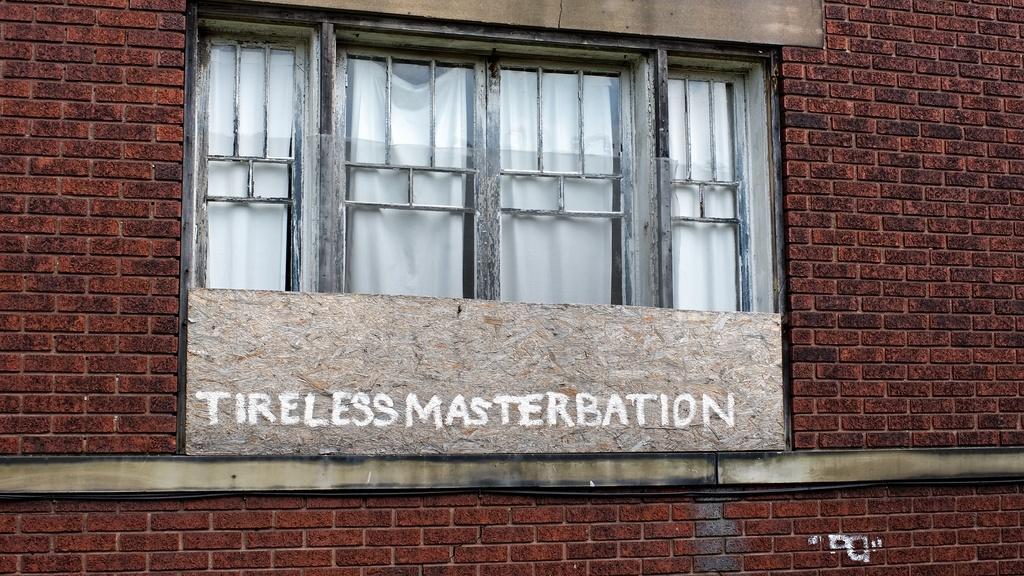Could you give a brief overview of what you see in this image? In this image, we can see brick walls, glass windows and board. On the board we can see some text. Through the glass we can see curtains. 